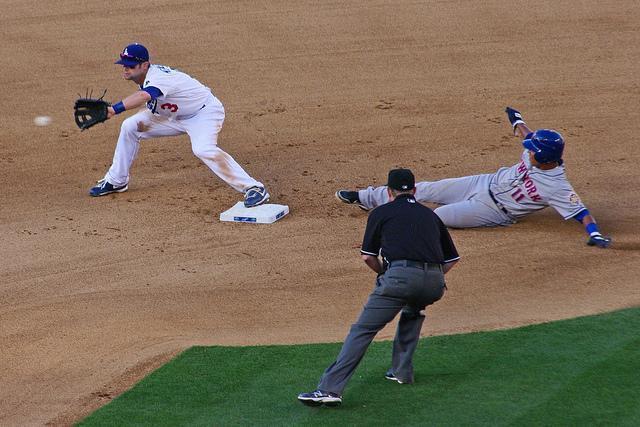How many people are in the photo?
Give a very brief answer. 3. 